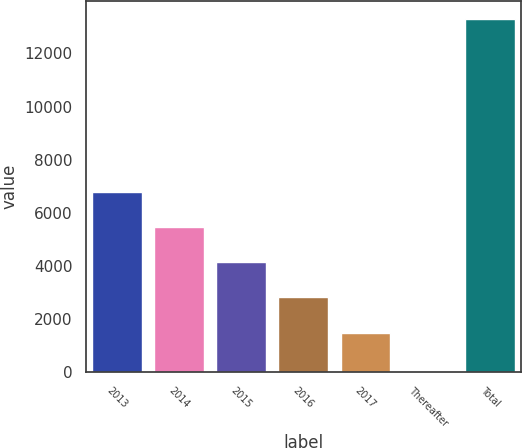Convert chart to OTSL. <chart><loc_0><loc_0><loc_500><loc_500><bar_chart><fcel>2013<fcel>2014<fcel>2015<fcel>2016<fcel>2017<fcel>Thereafter<fcel>Total<nl><fcel>6791<fcel>5463<fcel>4135<fcel>2807<fcel>1479<fcel>32<fcel>13312<nl></chart> 